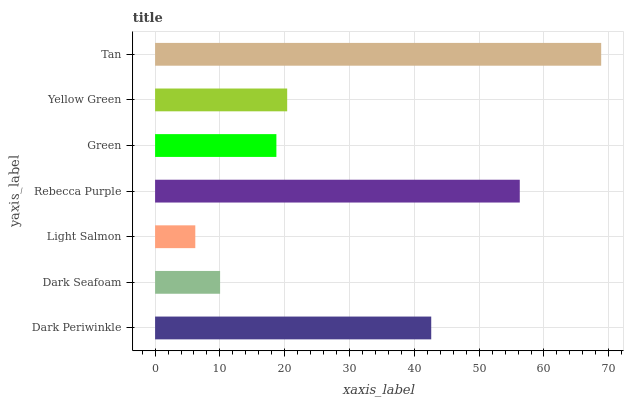Is Light Salmon the minimum?
Answer yes or no. Yes. Is Tan the maximum?
Answer yes or no. Yes. Is Dark Seafoam the minimum?
Answer yes or no. No. Is Dark Seafoam the maximum?
Answer yes or no. No. Is Dark Periwinkle greater than Dark Seafoam?
Answer yes or no. Yes. Is Dark Seafoam less than Dark Periwinkle?
Answer yes or no. Yes. Is Dark Seafoam greater than Dark Periwinkle?
Answer yes or no. No. Is Dark Periwinkle less than Dark Seafoam?
Answer yes or no. No. Is Yellow Green the high median?
Answer yes or no. Yes. Is Yellow Green the low median?
Answer yes or no. Yes. Is Rebecca Purple the high median?
Answer yes or no. No. Is Dark Periwinkle the low median?
Answer yes or no. No. 